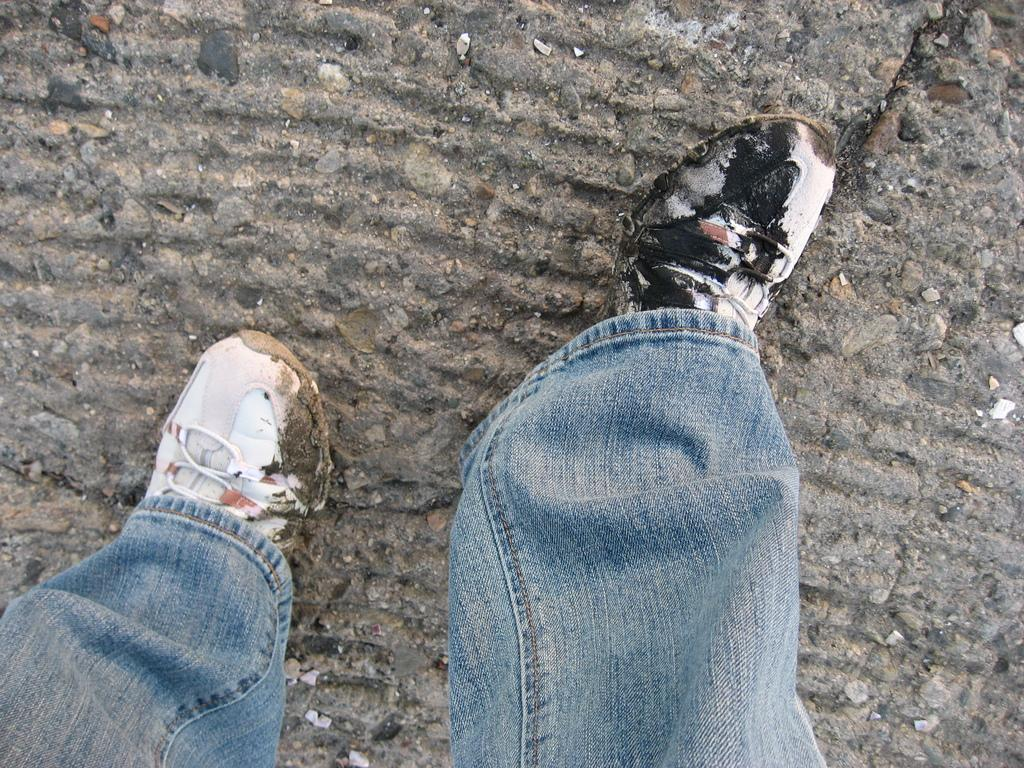What part of a person can be seen at the bottom of the image? There are legs of a person visible at the bottom of the image. How would you describe the appearance of the person's shoes? The person's shoes appear untidy. What type of surface is at the top of the image? There is a floor at the top of the image. What type of popcorn is being served in the image? There is no popcorn present in the image. Can you describe the taste of the tiger in the image? There is no tiger present in the image, so it is not possible to describe its taste. 